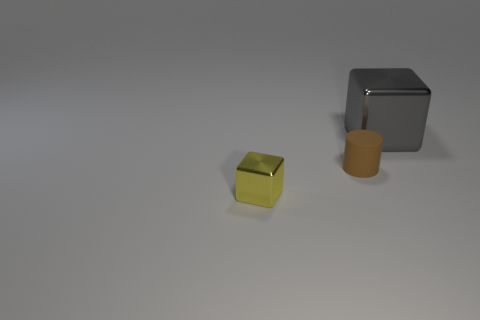Are there any other things that are the same size as the gray metallic object?
Your answer should be compact. No. Is the number of big gray cubes on the right side of the big gray shiny thing less than the number of small shiny things?
Ensure brevity in your answer.  Yes. How many big cyan metallic spheres are there?
Give a very brief answer. 0. Do the gray metal thing and the tiny object that is on the right side of the yellow metallic cube have the same shape?
Provide a short and direct response. No. Is the number of yellow metallic cubes that are behind the tiny rubber cylinder less than the number of gray cubes that are behind the small yellow shiny cube?
Your answer should be compact. Yes. Is there anything else that is the same shape as the brown rubber object?
Give a very brief answer. No. Is the shape of the large metal thing the same as the small brown rubber object?
Provide a short and direct response. No. Is there any other thing that has the same material as the yellow object?
Keep it short and to the point. Yes. The brown cylinder is what size?
Offer a very short reply. Small. What color is the object that is both in front of the large gray block and behind the small shiny block?
Give a very brief answer. Brown. 